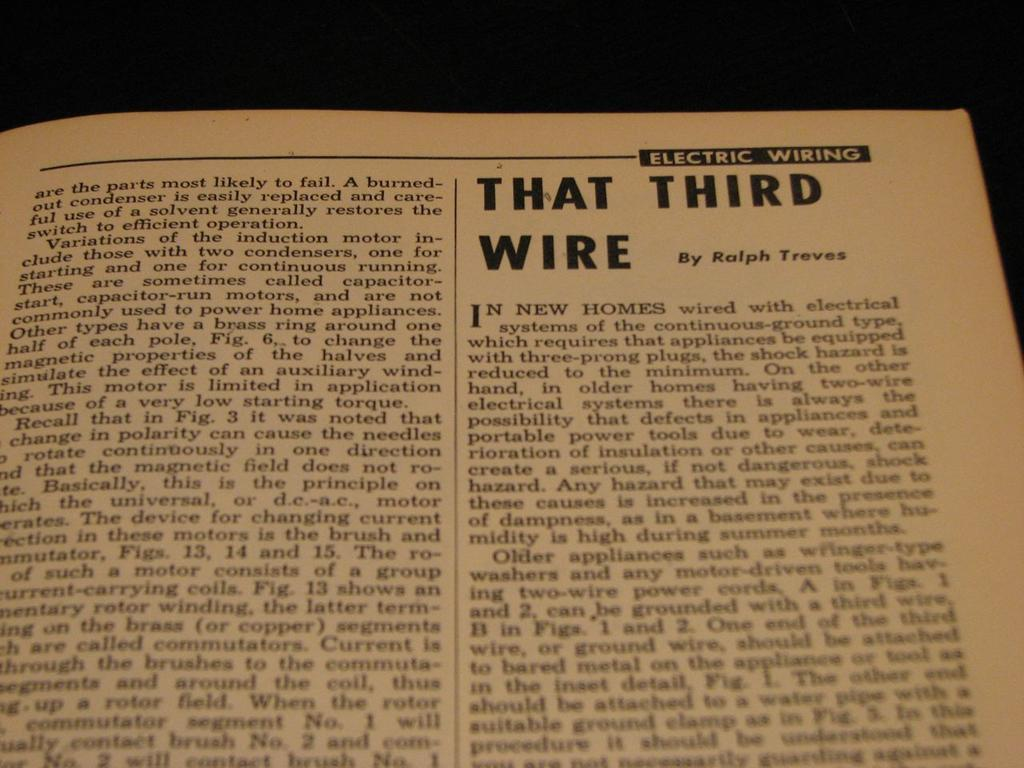<image>
Summarize the visual content of the image. A page has an article titled, "That Third Wire" by Ralph Treves. 